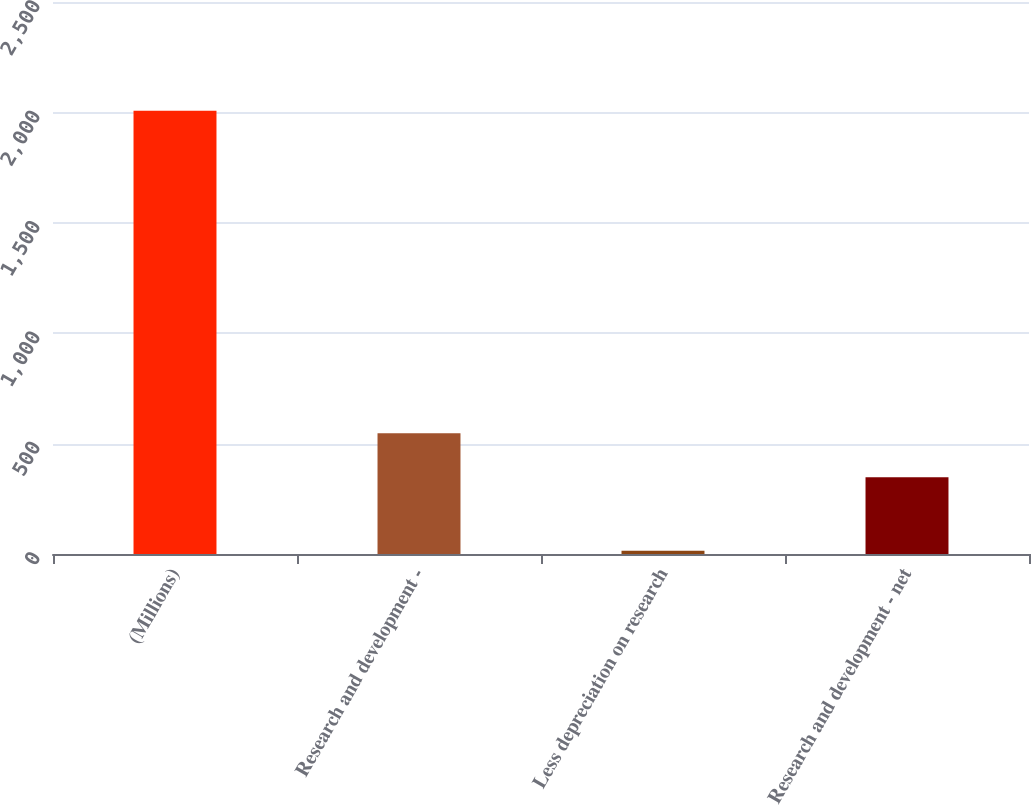Convert chart. <chart><loc_0><loc_0><loc_500><loc_500><bar_chart><fcel>(Millions)<fcel>Research and development -<fcel>Less depreciation on research<fcel>Research and development - net<nl><fcel>2007<fcel>547.2<fcel>15<fcel>348<nl></chart> 